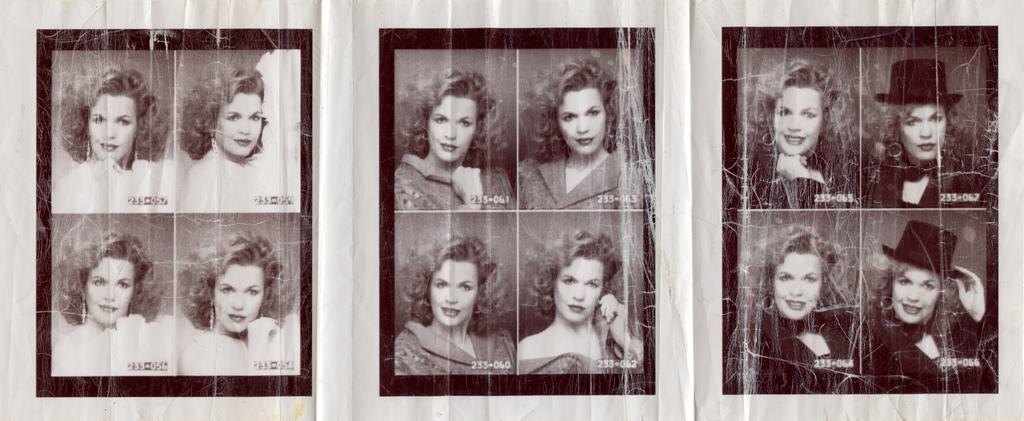What type of image is being described? The image is a collage. What can be seen in the collage? There are pictures of a woman in different outfits. What is the color scheme of the collage? The photos are black and white in color. How much money does the woman in the collage have in her hand? There is no indication of money or any financial transactions in the collage; it only features pictures of a woman in different outfits. 